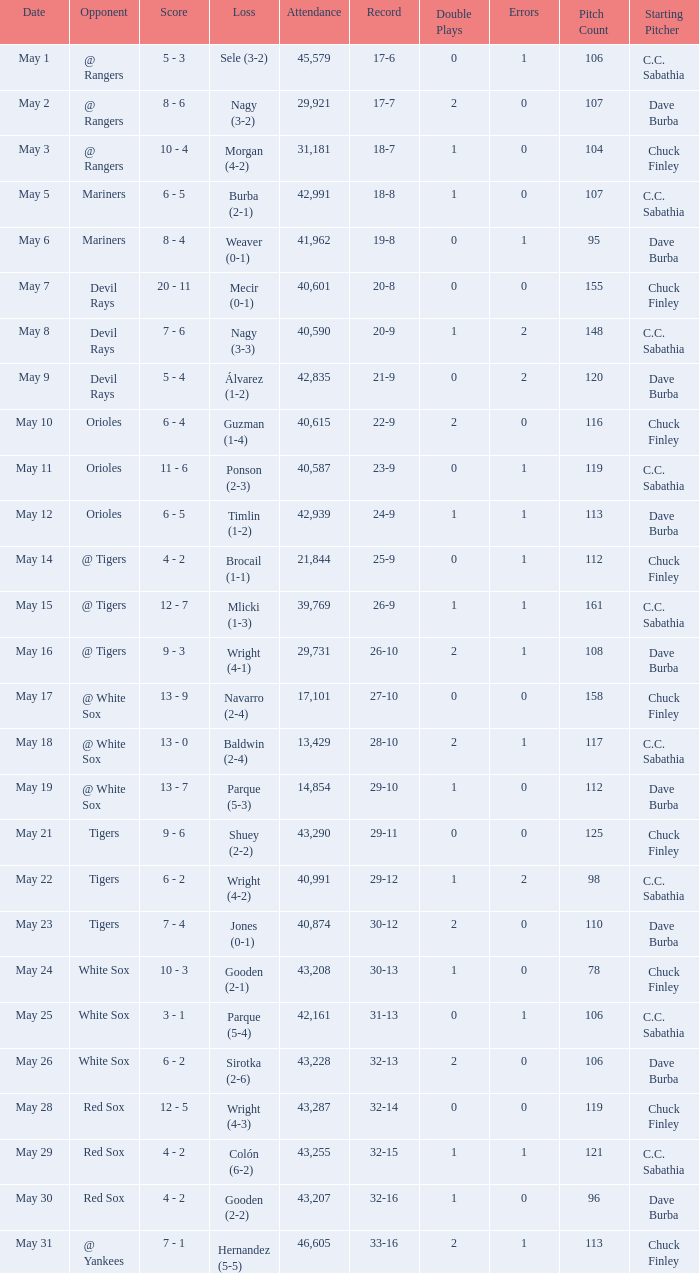What loss has 26-9 as a loss? Mlicki (1-3). 